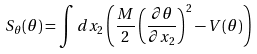<formula> <loc_0><loc_0><loc_500><loc_500>S _ { \theta } ( \theta ) = \int d x _ { 2 } \left ( { \frac { M } { 2 } } \left ( { \frac { \partial \theta } { \partial x _ { 2 } } } \right ) ^ { 2 } - V ( \theta ) \right )</formula> 